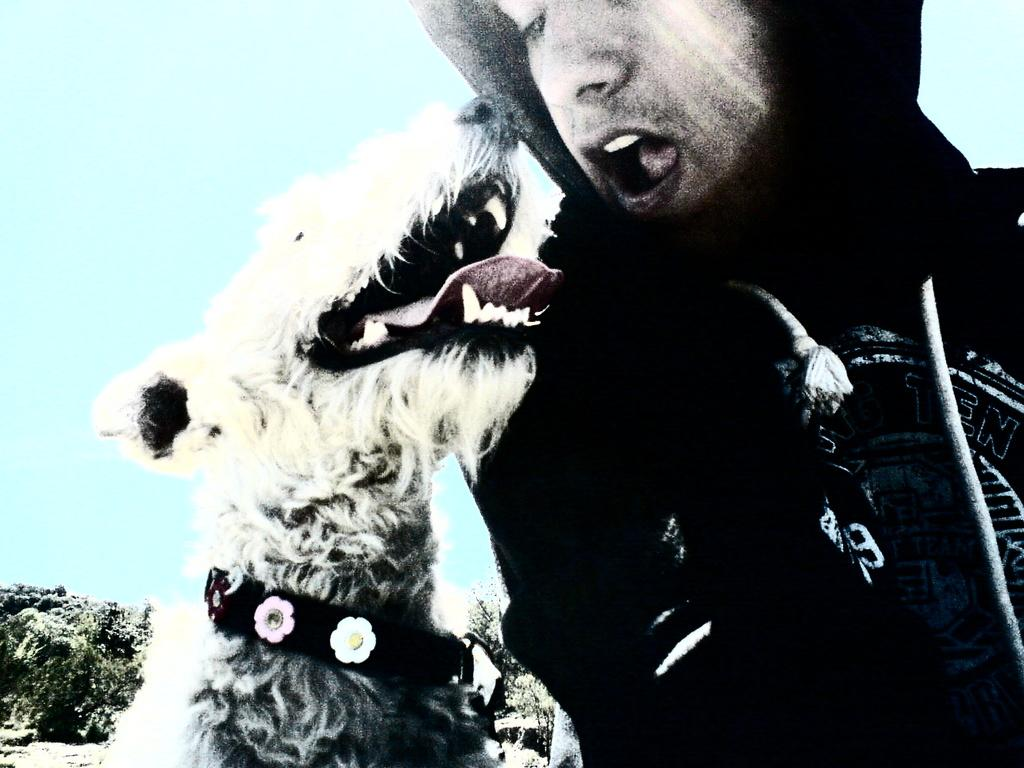Who is present in the image? There is a man in the image. What is the man doing in the image? The man is talking. What animal is beside the man in the image? There is a dog beside the man in the image. What can be seen in the background of the image? There is a tree and the sky visible in the background of the image. What type of calculator is the man using while talking in the image? There is no calculator present in the image; the man is simply talking. 